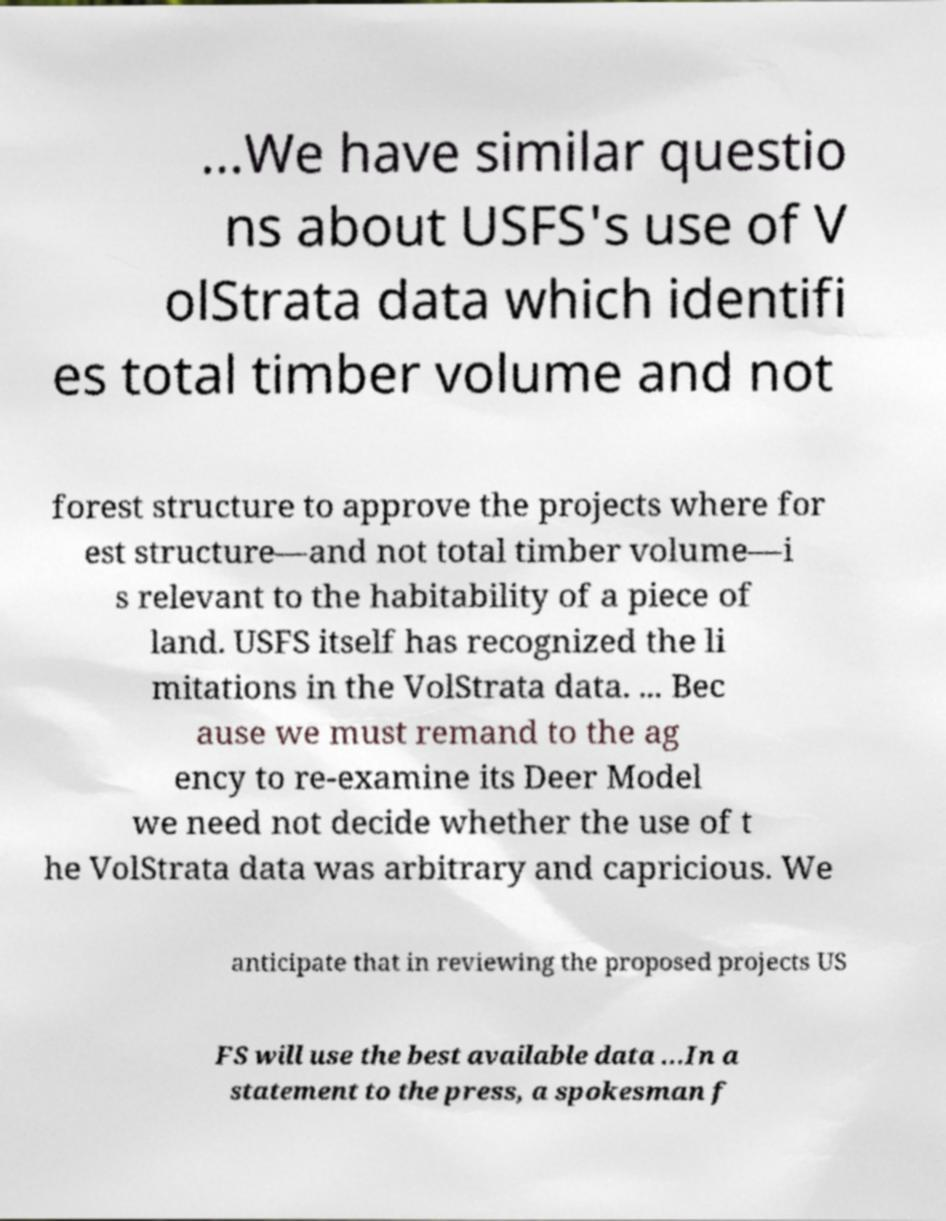There's text embedded in this image that I need extracted. Can you transcribe it verbatim? ...We have similar questio ns about USFS's use of V olStrata data which identifi es total timber volume and not forest structure to approve the projects where for est structure—and not total timber volume—i s relevant to the habitability of a piece of land. USFS itself has recognized the li mitations in the VolStrata data. ... Bec ause we must remand to the ag ency to re-examine its Deer Model we need not decide whether the use of t he VolStrata data was arbitrary and capricious. We anticipate that in reviewing the proposed projects US FS will use the best available data ...In a statement to the press, a spokesman f 